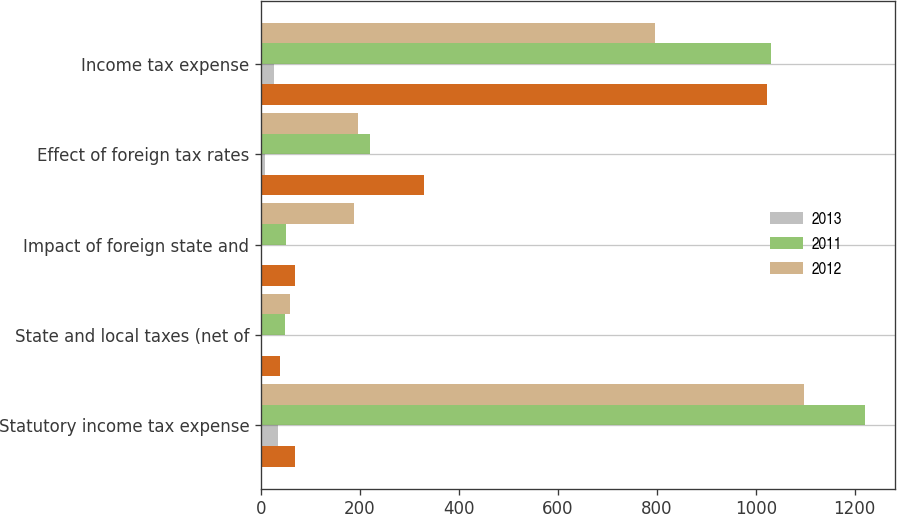Convert chart. <chart><loc_0><loc_0><loc_500><loc_500><stacked_bar_chart><ecel><fcel>Statutory income tax expense<fcel>State and local taxes (net of<fcel>Impact of foreign state and<fcel>Effect of foreign tax rates<fcel>Income tax expense<nl><fcel>nan<fcel>69<fcel>39<fcel>69<fcel>329<fcel>1022<nl><fcel>2013<fcel>35<fcel>1<fcel>2<fcel>8<fcel>26<nl><fcel>2011<fcel>1221<fcel>49<fcel>50<fcel>221<fcel>1030<nl><fcel>2012<fcel>1097<fcel>59<fcel>188<fcel>197<fcel>796<nl></chart> 